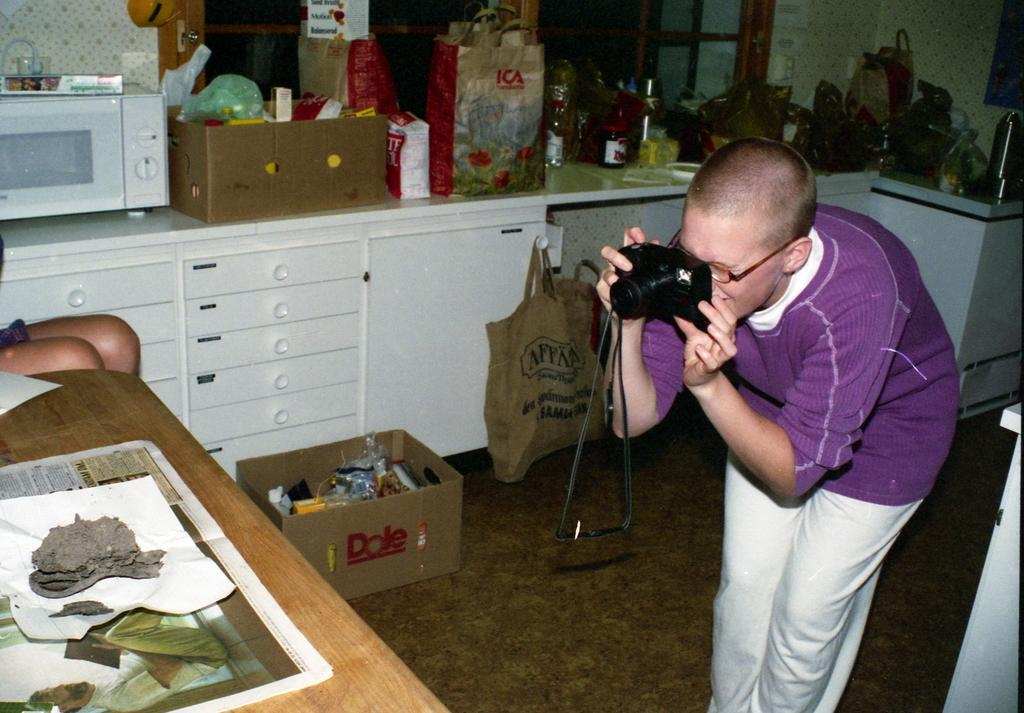<image>
Provide a brief description of the given image. A photographer snaps a shot while a Dole box sits on the floor in the background. 